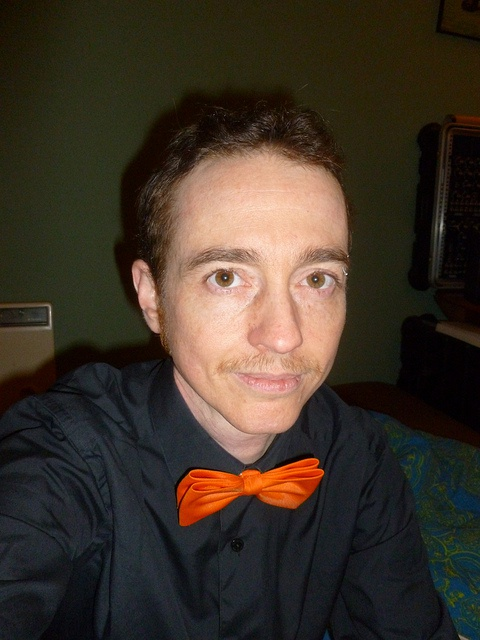Describe the objects in this image and their specific colors. I can see people in black, tan, and gray tones and tie in black, red, and brown tones in this image. 